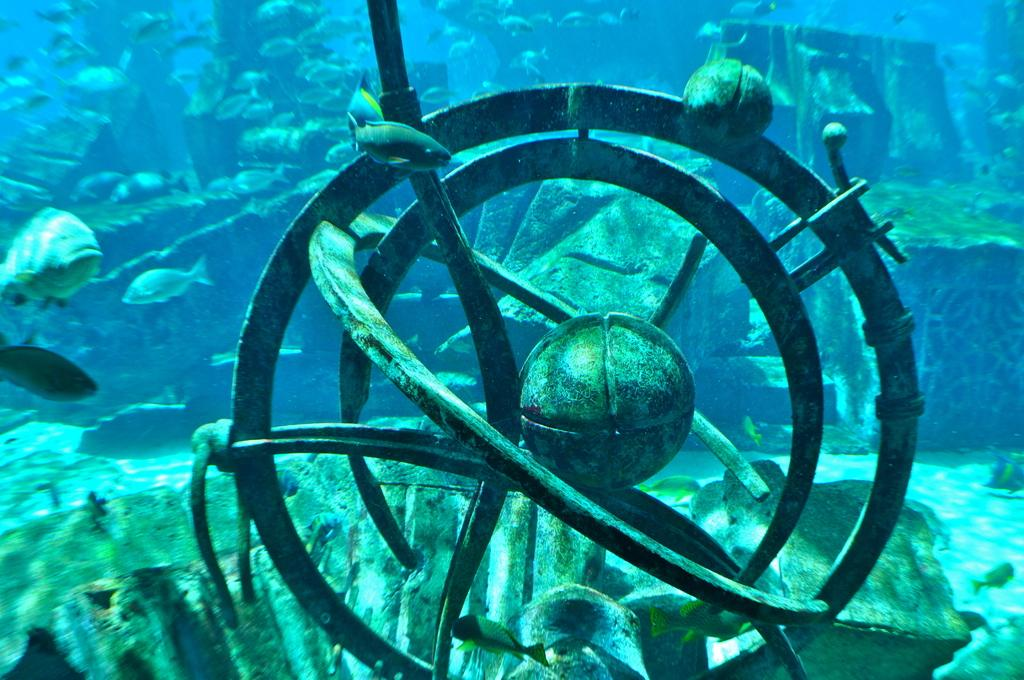What type of animals can be seen in the image? There are fishes in the image. What is the primary element in which the fishes are situated? The fishes are situated in water. Can you describe any other objects present in the water? There are objects in the water in the image. What type of banana can be seen floating in the water in the image? There is no banana present in the image; it only features fishes and objects in the water. 